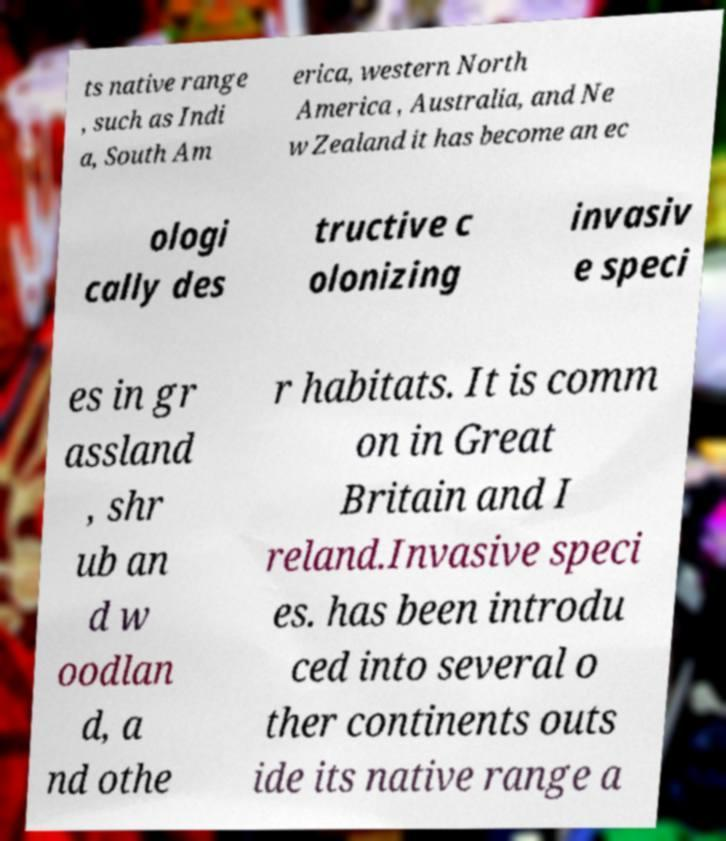Can you read and provide the text displayed in the image?This photo seems to have some interesting text. Can you extract and type it out for me? ts native range , such as Indi a, South Am erica, western North America , Australia, and Ne w Zealand it has become an ec ologi cally des tructive c olonizing invasiv e speci es in gr assland , shr ub an d w oodlan d, a nd othe r habitats. It is comm on in Great Britain and I reland.Invasive speci es. has been introdu ced into several o ther continents outs ide its native range a 